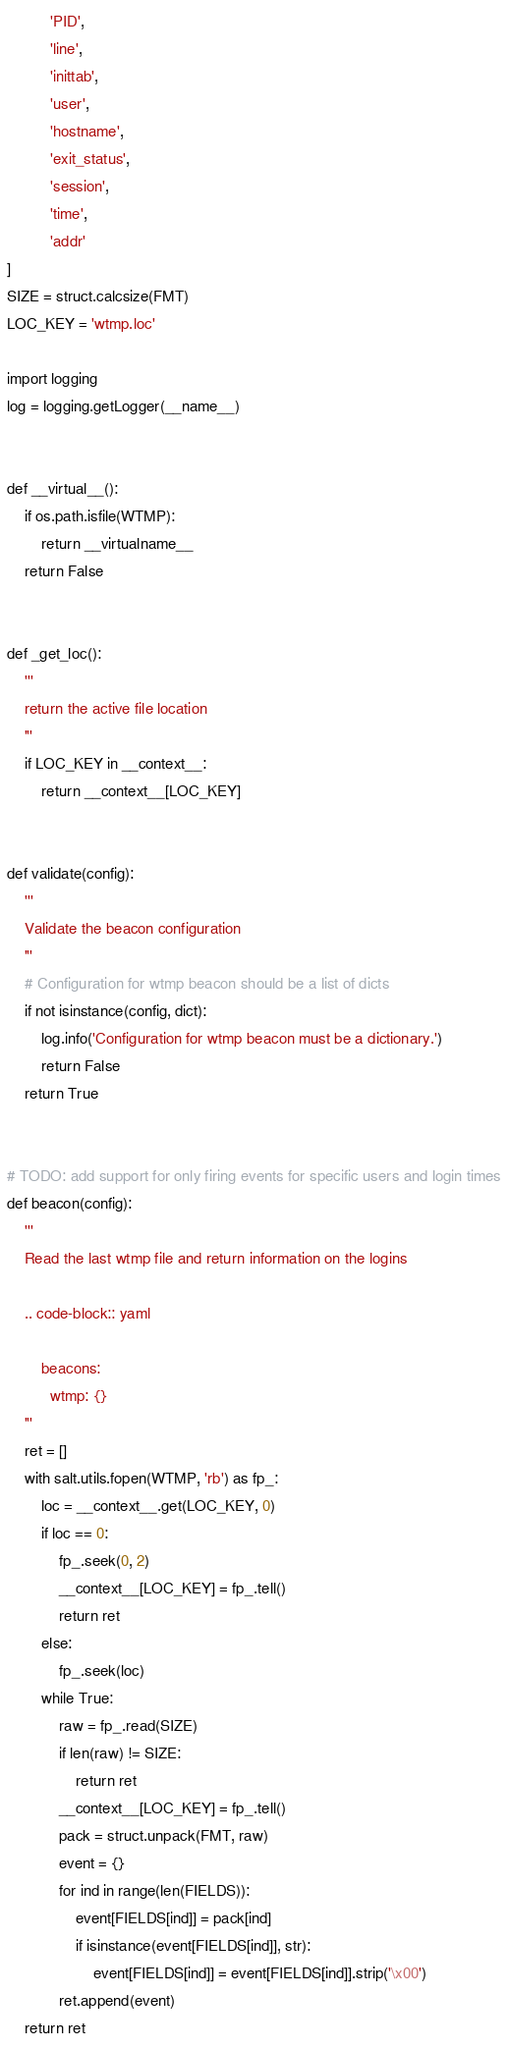Convert code to text. <code><loc_0><loc_0><loc_500><loc_500><_Python_>          'PID',
          'line',
          'inittab',
          'user',
          'hostname',
          'exit_status',
          'session',
          'time',
          'addr'
]
SIZE = struct.calcsize(FMT)
LOC_KEY = 'wtmp.loc'

import logging
log = logging.getLogger(__name__)


def __virtual__():
    if os.path.isfile(WTMP):
        return __virtualname__
    return False


def _get_loc():
    '''
    return the active file location
    '''
    if LOC_KEY in __context__:
        return __context__[LOC_KEY]


def validate(config):
    '''
    Validate the beacon configuration
    '''
    # Configuration for wtmp beacon should be a list of dicts
    if not isinstance(config, dict):
        log.info('Configuration for wtmp beacon must be a dictionary.')
        return False
    return True


# TODO: add support for only firing events for specific users and login times
def beacon(config):
    '''
    Read the last wtmp file and return information on the logins

    .. code-block:: yaml

        beacons:
          wtmp: {}
    '''
    ret = []
    with salt.utils.fopen(WTMP, 'rb') as fp_:
        loc = __context__.get(LOC_KEY, 0)
        if loc == 0:
            fp_.seek(0, 2)
            __context__[LOC_KEY] = fp_.tell()
            return ret
        else:
            fp_.seek(loc)
        while True:
            raw = fp_.read(SIZE)
            if len(raw) != SIZE:
                return ret
            __context__[LOC_KEY] = fp_.tell()
            pack = struct.unpack(FMT, raw)
            event = {}
            for ind in range(len(FIELDS)):
                event[FIELDS[ind]] = pack[ind]
                if isinstance(event[FIELDS[ind]], str):
                    event[FIELDS[ind]] = event[FIELDS[ind]].strip('\x00')
            ret.append(event)
    return ret
</code> 